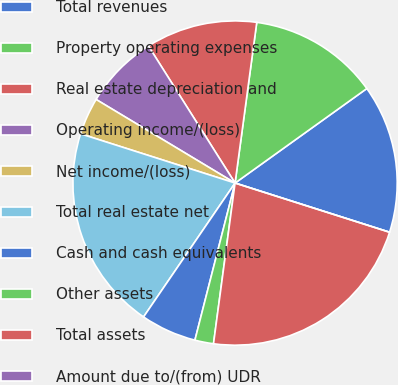<chart> <loc_0><loc_0><loc_500><loc_500><pie_chart><fcel>Total revenues<fcel>Property operating expenses<fcel>Real estate depreciation and<fcel>Operating income/(loss)<fcel>Net income/(loss)<fcel>Total real estate net<fcel>Cash and cash equivalents<fcel>Other assets<fcel>Total assets<fcel>Amount due to/(from) UDR<nl><fcel>14.81%<fcel>12.96%<fcel>11.11%<fcel>7.41%<fcel>3.71%<fcel>20.37%<fcel>5.56%<fcel>1.86%<fcel>22.22%<fcel>0.0%<nl></chart> 